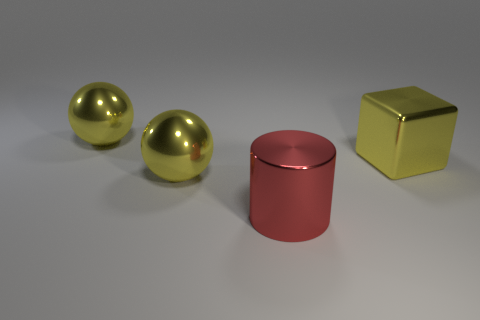Is the color of the shiny thing that is right of the big metal cylinder the same as the metal cylinder?
Offer a very short reply. No. What number of big things have the same color as the cube?
Your answer should be very brief. 2. Is the number of big yellow spheres behind the big cylinder greater than the number of large red rubber cylinders?
Offer a very short reply. Yes. What is the shape of the red object?
Offer a very short reply. Cylinder. Do the big object right of the cylinder and the ball that is in front of the yellow block have the same color?
Offer a very short reply. Yes. Is there anything else that is the same shape as the big red thing?
Keep it short and to the point. No. Does the yellow sphere in front of the yellow metal cube have the same material as the cube?
Provide a succinct answer. Yes. There is a thing that is both in front of the large cube and behind the red metal thing; what shape is it?
Offer a very short reply. Sphere. There is a large thing on the right side of the red metal thing; is there a cylinder behind it?
Your answer should be very brief. No. What number of other things are the same material as the red thing?
Offer a terse response. 3. 